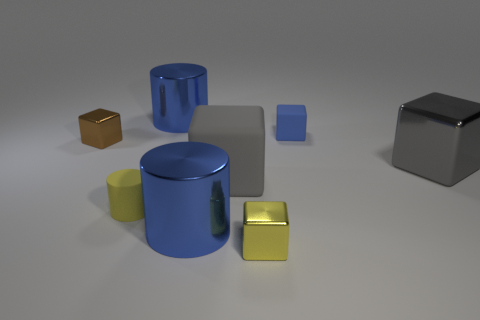Subtract all purple balls. How many gray blocks are left? 2 Subtract 2 blocks. How many blocks are left? 3 Subtract all yellow shiny cubes. How many cubes are left? 4 Subtract all blue blocks. How many blocks are left? 4 Add 2 blue objects. How many objects exist? 10 Subtract all purple cubes. Subtract all red spheres. How many cubes are left? 5 Subtract all cubes. How many objects are left? 3 Subtract all yellow cylinders. Subtract all big shiny cylinders. How many objects are left? 5 Add 3 metal things. How many metal things are left? 8 Add 2 small brown cubes. How many small brown cubes exist? 3 